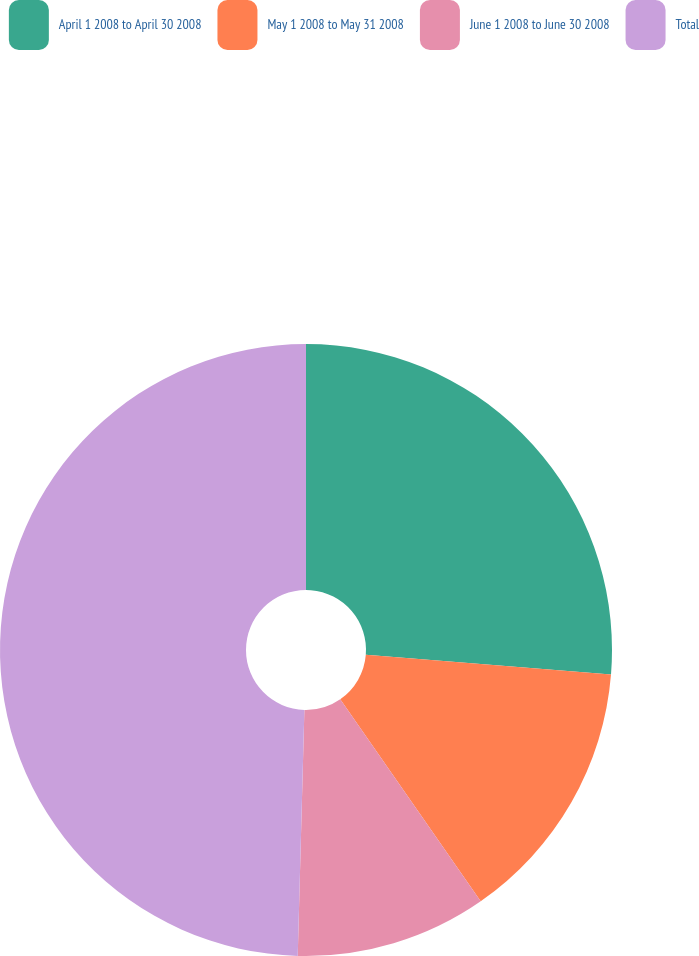<chart> <loc_0><loc_0><loc_500><loc_500><pie_chart><fcel>April 1 2008 to April 30 2008<fcel>May 1 2008 to May 31 2008<fcel>June 1 2008 to June 30 2008<fcel>Total<nl><fcel>26.28%<fcel>14.05%<fcel>10.1%<fcel>49.57%<nl></chart> 